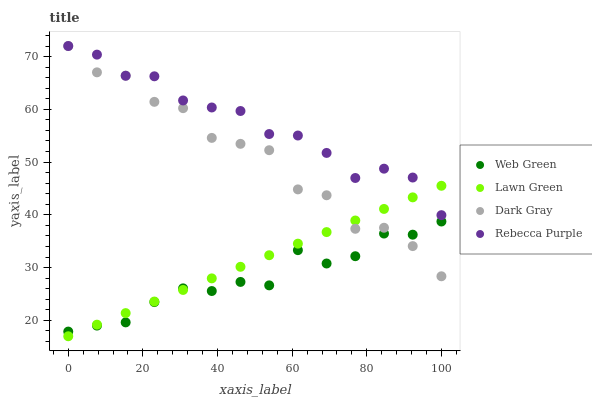Does Web Green have the minimum area under the curve?
Answer yes or no. Yes. Does Rebecca Purple have the maximum area under the curve?
Answer yes or no. Yes. Does Lawn Green have the minimum area under the curve?
Answer yes or no. No. Does Lawn Green have the maximum area under the curve?
Answer yes or no. No. Is Lawn Green the smoothest?
Answer yes or no. Yes. Is Dark Gray the roughest?
Answer yes or no. Yes. Is Rebecca Purple the smoothest?
Answer yes or no. No. Is Rebecca Purple the roughest?
Answer yes or no. No. Does Lawn Green have the lowest value?
Answer yes or no. Yes. Does Rebecca Purple have the lowest value?
Answer yes or no. No. Does Rebecca Purple have the highest value?
Answer yes or no. Yes. Does Lawn Green have the highest value?
Answer yes or no. No. Is Web Green less than Rebecca Purple?
Answer yes or no. Yes. Is Rebecca Purple greater than Web Green?
Answer yes or no. Yes. Does Dark Gray intersect Lawn Green?
Answer yes or no. Yes. Is Dark Gray less than Lawn Green?
Answer yes or no. No. Is Dark Gray greater than Lawn Green?
Answer yes or no. No. Does Web Green intersect Rebecca Purple?
Answer yes or no. No. 